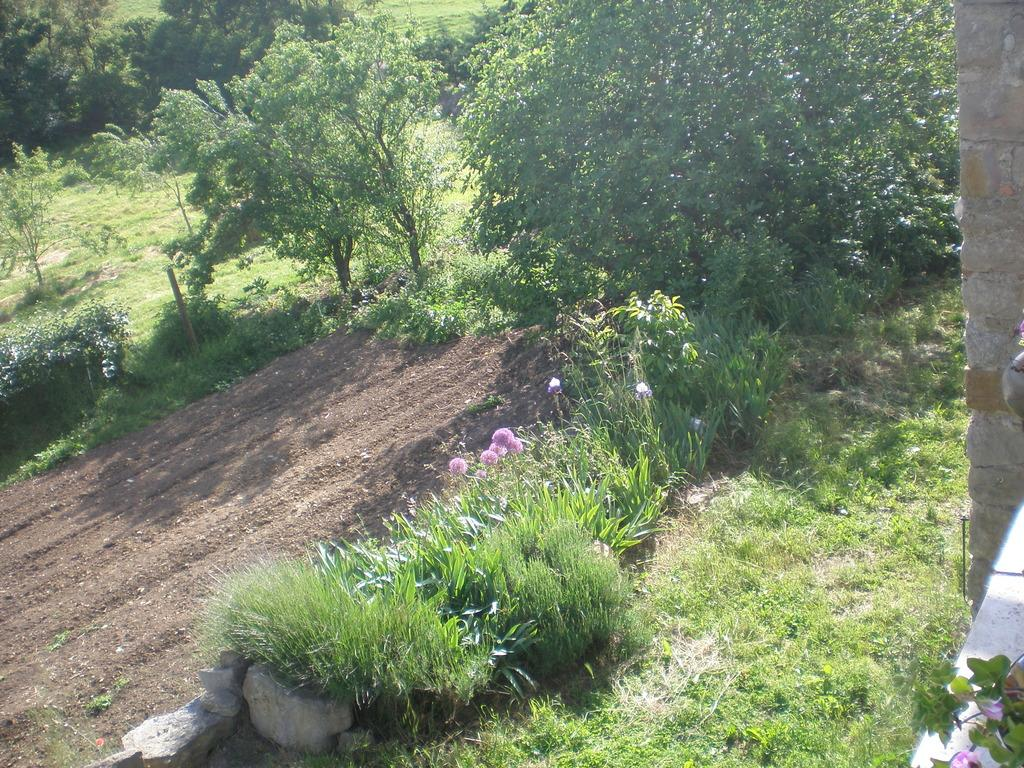What is located in the center of the image? There are trees in the center of the image. What type of vegetation is at the bottom of the image? There is grass at the bottom of the image. Are there any plants other than trees and grass in the image? Yes, flowers are visible in the image. What type of advertisement can be seen on the cheese in the image? There is no advertisement or cheese present in the image; it features trees, grass, and flowers. 